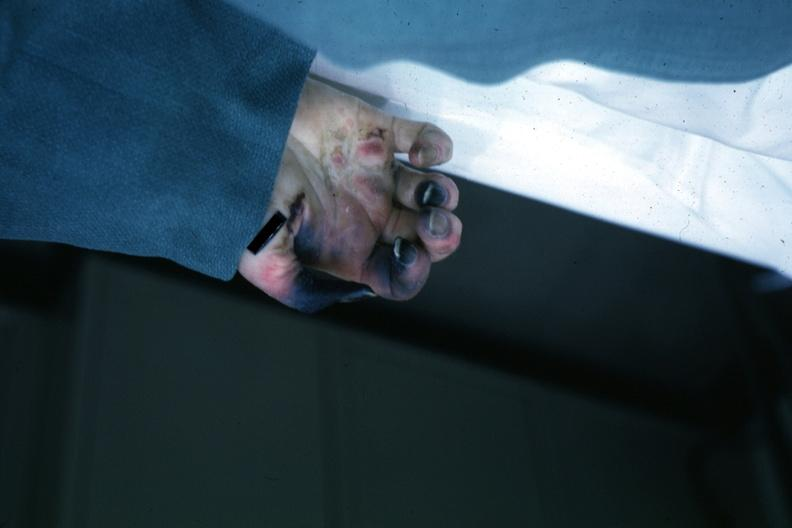does this image show obvious gangrenous necrosis due to shock or embolism postoperative cardiac surgery?
Answer the question using a single word or phrase. Yes 